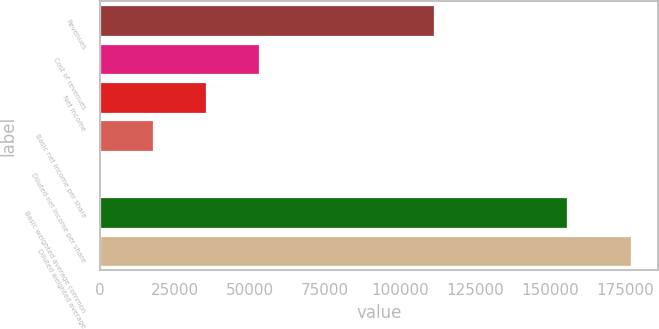Convert chart to OTSL. <chart><loc_0><loc_0><loc_500><loc_500><bar_chart><fcel>Revenues<fcel>Cost of revenues<fcel>Net income<fcel>Basic net income per share<fcel>Diluted net income per share<fcel>Basic weighted average common<fcel>Diluted weighted average<nl><fcel>111495<fcel>53118.9<fcel>35412.7<fcel>17706.4<fcel>0.08<fcel>155739<fcel>177063<nl></chart> 